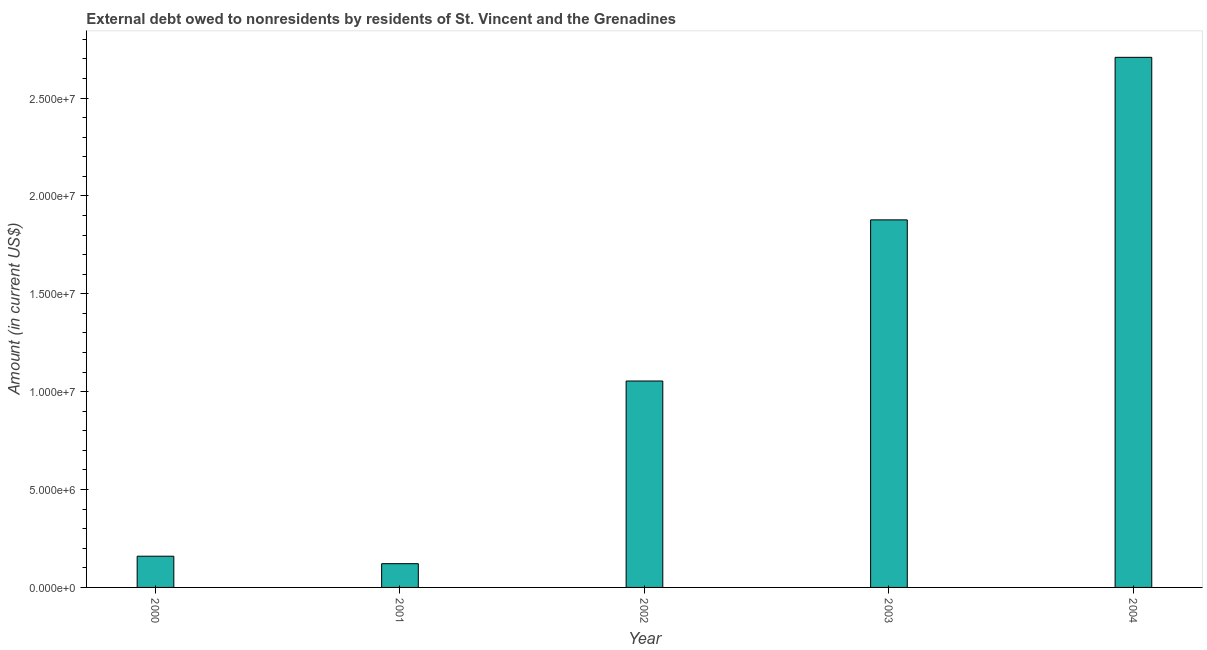Does the graph contain any zero values?
Offer a terse response. No. Does the graph contain grids?
Offer a very short reply. No. What is the title of the graph?
Your response must be concise. External debt owed to nonresidents by residents of St. Vincent and the Grenadines. What is the label or title of the X-axis?
Give a very brief answer. Year. What is the label or title of the Y-axis?
Your answer should be very brief. Amount (in current US$). What is the debt in 2000?
Provide a short and direct response. 1.60e+06. Across all years, what is the maximum debt?
Your answer should be very brief. 2.71e+07. Across all years, what is the minimum debt?
Your answer should be compact. 1.21e+06. In which year was the debt maximum?
Offer a very short reply. 2004. In which year was the debt minimum?
Your answer should be very brief. 2001. What is the sum of the debt?
Give a very brief answer. 5.92e+07. What is the difference between the debt in 2002 and 2004?
Offer a very short reply. -1.65e+07. What is the average debt per year?
Your answer should be compact. 1.18e+07. What is the median debt?
Your answer should be compact. 1.05e+07. What is the ratio of the debt in 2000 to that in 2001?
Provide a succinct answer. 1.31. Is the difference between the debt in 2002 and 2003 greater than the difference between any two years?
Give a very brief answer. No. What is the difference between the highest and the second highest debt?
Your answer should be very brief. 8.30e+06. Is the sum of the debt in 2000 and 2003 greater than the maximum debt across all years?
Give a very brief answer. No. What is the difference between the highest and the lowest debt?
Your response must be concise. 2.59e+07. How many years are there in the graph?
Your response must be concise. 5. What is the difference between two consecutive major ticks on the Y-axis?
Give a very brief answer. 5.00e+06. Are the values on the major ticks of Y-axis written in scientific E-notation?
Your answer should be compact. Yes. What is the Amount (in current US$) of 2000?
Your answer should be very brief. 1.60e+06. What is the Amount (in current US$) in 2001?
Offer a very short reply. 1.21e+06. What is the Amount (in current US$) in 2002?
Offer a terse response. 1.05e+07. What is the Amount (in current US$) in 2003?
Your answer should be compact. 1.88e+07. What is the Amount (in current US$) in 2004?
Provide a short and direct response. 2.71e+07. What is the difference between the Amount (in current US$) in 2000 and 2001?
Offer a terse response. 3.82e+05. What is the difference between the Amount (in current US$) in 2000 and 2002?
Give a very brief answer. -8.95e+06. What is the difference between the Amount (in current US$) in 2000 and 2003?
Provide a short and direct response. -1.72e+07. What is the difference between the Amount (in current US$) in 2000 and 2004?
Your answer should be compact. -2.55e+07. What is the difference between the Amount (in current US$) in 2001 and 2002?
Ensure brevity in your answer.  -9.33e+06. What is the difference between the Amount (in current US$) in 2001 and 2003?
Your response must be concise. -1.76e+07. What is the difference between the Amount (in current US$) in 2001 and 2004?
Your response must be concise. -2.59e+07. What is the difference between the Amount (in current US$) in 2002 and 2003?
Your answer should be compact. -8.23e+06. What is the difference between the Amount (in current US$) in 2002 and 2004?
Your answer should be very brief. -1.65e+07. What is the difference between the Amount (in current US$) in 2003 and 2004?
Provide a short and direct response. -8.30e+06. What is the ratio of the Amount (in current US$) in 2000 to that in 2001?
Make the answer very short. 1.31. What is the ratio of the Amount (in current US$) in 2000 to that in 2002?
Your answer should be very brief. 0.15. What is the ratio of the Amount (in current US$) in 2000 to that in 2003?
Your response must be concise. 0.09. What is the ratio of the Amount (in current US$) in 2000 to that in 2004?
Your response must be concise. 0.06. What is the ratio of the Amount (in current US$) in 2001 to that in 2002?
Offer a terse response. 0.12. What is the ratio of the Amount (in current US$) in 2001 to that in 2003?
Provide a succinct answer. 0.07. What is the ratio of the Amount (in current US$) in 2001 to that in 2004?
Your answer should be very brief. 0.04. What is the ratio of the Amount (in current US$) in 2002 to that in 2003?
Provide a succinct answer. 0.56. What is the ratio of the Amount (in current US$) in 2002 to that in 2004?
Your answer should be very brief. 0.39. What is the ratio of the Amount (in current US$) in 2003 to that in 2004?
Provide a short and direct response. 0.69. 